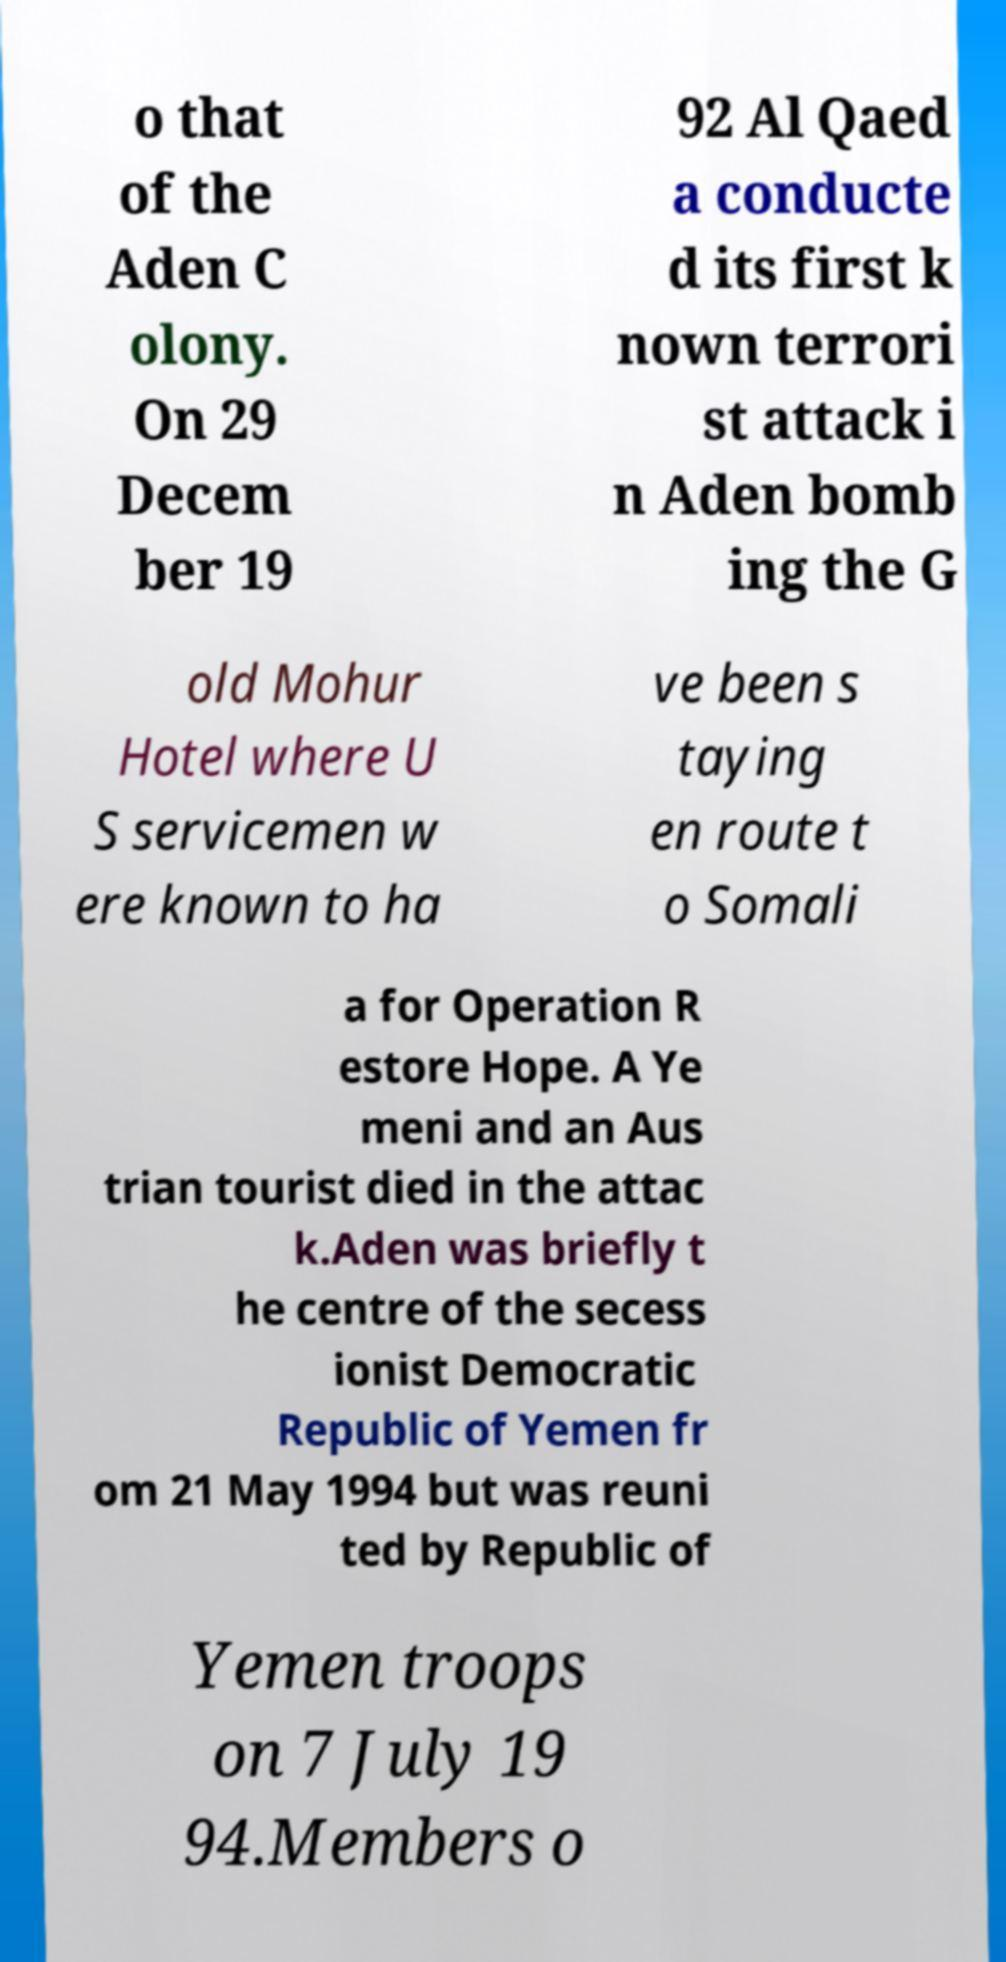Please identify and transcribe the text found in this image. o that of the Aden C olony. On 29 Decem ber 19 92 Al Qaed a conducte d its first k nown terrori st attack i n Aden bomb ing the G old Mohur Hotel where U S servicemen w ere known to ha ve been s taying en route t o Somali a for Operation R estore Hope. A Ye meni and an Aus trian tourist died in the attac k.Aden was briefly t he centre of the secess ionist Democratic Republic of Yemen fr om 21 May 1994 but was reuni ted by Republic of Yemen troops on 7 July 19 94.Members o 